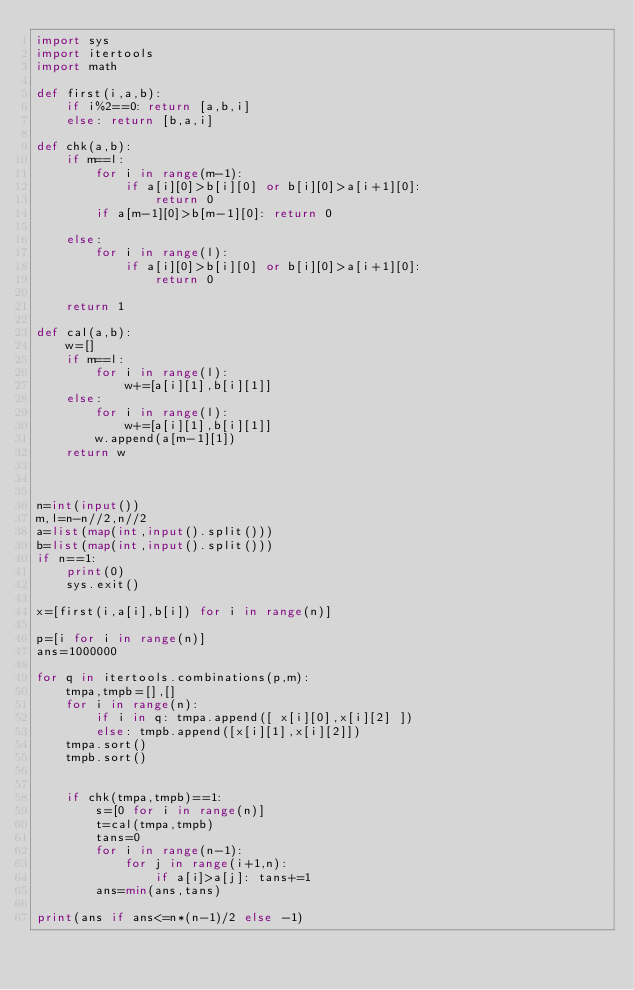<code> <loc_0><loc_0><loc_500><loc_500><_Python_>import sys
import itertools
import math

def first(i,a,b):
    if i%2==0: return [a,b,i]
    else: return [b,a,i]

def chk(a,b):
    if m==l:
        for i in range(m-1):
            if a[i][0]>b[i][0] or b[i][0]>a[i+1][0]:
                return 0
        if a[m-1][0]>b[m-1][0]: return 0
            
    else:
        for i in range(l):
            if a[i][0]>b[i][0] or b[i][0]>a[i+1][0]:
                return 0

    return 1

def cal(a,b):
    w=[]
    if m==l:
        for i in range(l):
            w+=[a[i][1],b[i][1]]
    else:
        for i in range(l):
            w+=[a[i][1],b[i][1]]
        w.append(a[m-1][1])
    return w
        


n=int(input())
m,l=n-n//2,n//2
a=list(map(int,input().split()))
b=list(map(int,input().split()))
if n==1:
    print(0)
    sys.exit()

x=[first(i,a[i],b[i]) for i in range(n)]

p=[i for i in range(n)]
ans=1000000

for q in itertools.combinations(p,m):
    tmpa,tmpb=[],[]
    for i in range(n):
        if i in q: tmpa.append([ x[i][0],x[i][2] ])
        else: tmpb.append([x[i][1],x[i][2]])
    tmpa.sort()
    tmpb.sort()


    if chk(tmpa,tmpb)==1:
        s=[0 for i in range(n)]
        t=cal(tmpa,tmpb)
        tans=0
        for i in range(n-1):
            for j in range(i+1,n):
                if a[i]>a[j]: tans+=1
        ans=min(ans,tans)

print(ans if ans<=n*(n-1)/2 else -1)</code> 